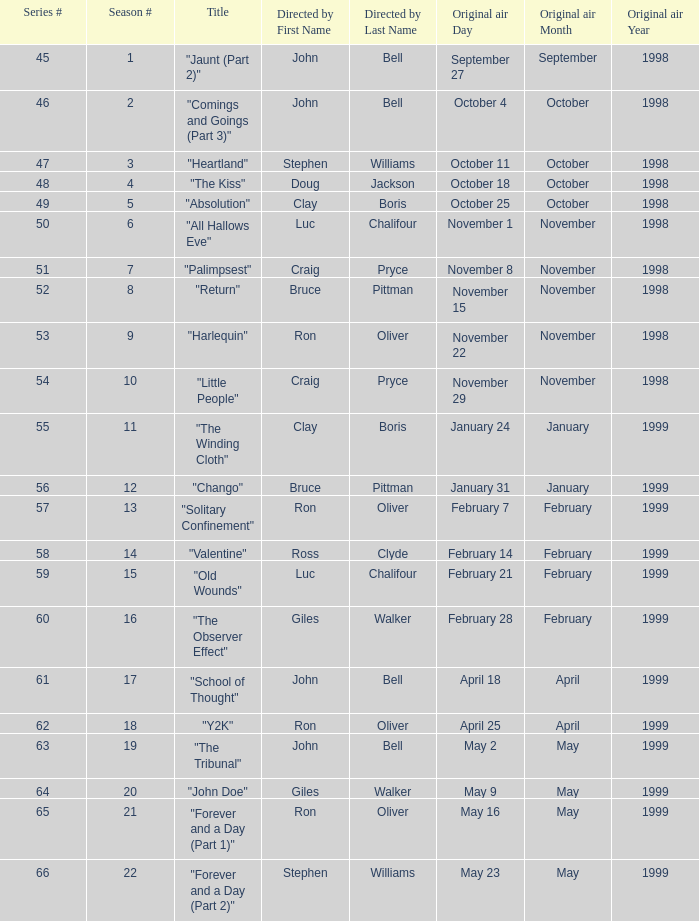Would you be able to parse every entry in this table? {'header': ['Series #', 'Season #', 'Title', 'Directed by First Name', 'Directed by Last Name', 'Original air Day', 'Original air Month', 'Original air Year'], 'rows': [['45', '1', '"Jaunt (Part 2)"', 'John', 'Bell', 'September 27', 'September', '1998'], ['46', '2', '"Comings and Goings (Part 3)"', 'John', 'Bell', 'October 4', 'October', '1998'], ['47', '3', '"Heartland"', 'Stephen', 'Williams', 'October 11', 'October', '1998'], ['48', '4', '"The Kiss"', 'Doug', 'Jackson', 'October 18', 'October', '1998'], ['49', '5', '"Absolution"', 'Clay', 'Boris', 'October 25', 'October', '1998'], ['50', '6', '"All Hallows Eve"', 'Luc', 'Chalifour', 'November 1', 'November', '1998'], ['51', '7', '"Palimpsest"', 'Craig', 'Pryce', 'November 8', 'November', '1998'], ['52', '8', '"Return"', 'Bruce', 'Pittman', 'November 15', 'November', '1998'], ['53', '9', '"Harlequin"', 'Ron', 'Oliver', 'November 22', 'November', '1998'], ['54', '10', '"Little People"', 'Craig', 'Pryce', 'November 29', 'November', '1998'], ['55', '11', '"The Winding Cloth"', 'Clay', 'Boris', 'January 24', 'January', '1999'], ['56', '12', '"Chango"', 'Bruce', 'Pittman', 'January 31', 'January', '1999'], ['57', '13', '"Solitary Confinement"', 'Ron', 'Oliver', 'February 7', 'February', '1999'], ['58', '14', '"Valentine"', 'Ross', 'Clyde', 'February 14', 'February', '1999'], ['59', '15', '"Old Wounds"', 'Luc', 'Chalifour', 'February 21', 'February', '1999'], ['60', '16', '"The Observer Effect"', 'Giles', 'Walker', 'February 28', 'February', '1999'], ['61', '17', '"School of Thought"', 'John', 'Bell', 'April 18', 'April', '1999'], ['62', '18', '"Y2K"', 'Ron', 'Oliver', 'April 25', 'April', '1999'], ['63', '19', '"The Tribunal"', 'John', 'Bell', 'May 2', 'May', '1999'], ['64', '20', '"John Doe"', 'Giles', 'Walker', 'May 9', 'May', '1999'], ['65', '21', '"Forever and a Day (Part 1)"', 'Ron', 'Oliver', 'May 16', 'May', '1999'], ['66', '22', '"Forever and a Day (Part 2)"', 'Stephen', 'Williams', 'May 23', 'May', '1999']]} Which Original air date has a Season # smaller than 21, and a Title of "palimpsest"? November 8, 1998. 